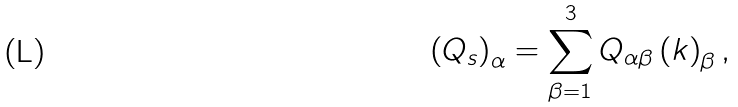Convert formula to latex. <formula><loc_0><loc_0><loc_500><loc_500>\left ( { Q } _ { s } \right ) _ { \alpha } = \sum ^ { 3 } _ { \beta = 1 } Q _ { \alpha \beta } \left ( { k } \right ) _ { \beta } ,</formula> 